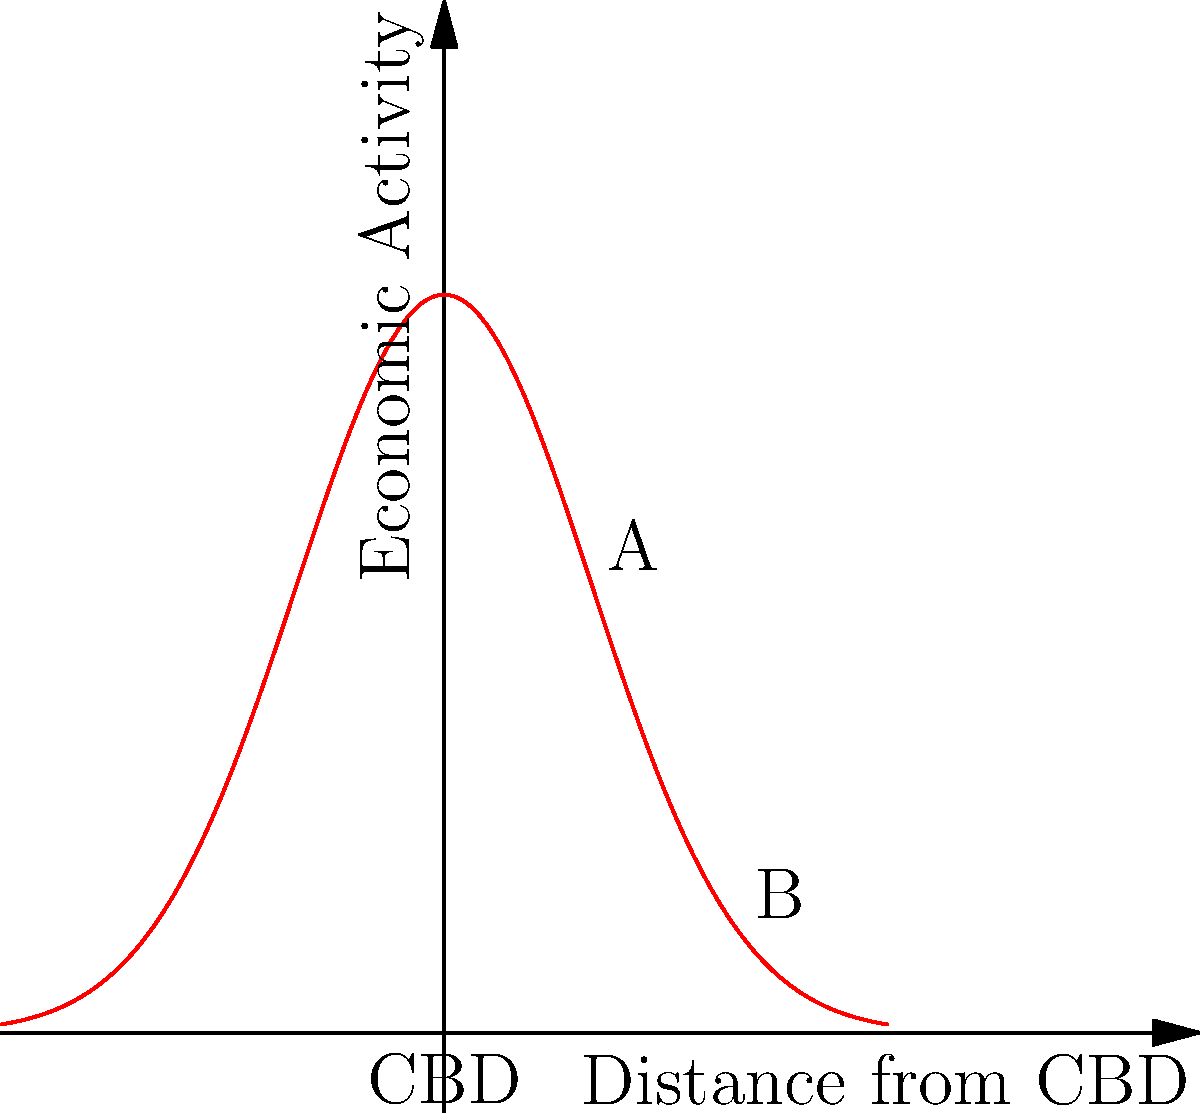The graph represents the distribution of economic activity in an urban area, with the Central Business District (CBD) at the origin. If vector $\vec{v} = \langle 2, f(2) - f(1) \rangle$ represents the change in economic activity from point A to B, what is the magnitude of $\vec{v}$? To find the magnitude of vector $\vec{v}$, we need to follow these steps:

1) First, we need to calculate $f(1)$ and $f(2)$:
   $f(x) = 5e^{-0.5x^2}$
   $f(1) = 5e^{-0.5} \approx 3.03$
   $f(2) = 5e^{-2} \approx 0.68$

2) Now we can define vector $\vec{v}$:
   $\vec{v} = \langle 2, f(2) - f(1) \rangle = \langle 2, 0.68 - 3.03 \rangle = \langle 2, -2.35 \rangle$

3) The magnitude of a vector $\vec{v} = \langle a, b \rangle$ is given by $\|\vec{v}\| = \sqrt{a^2 + b^2}$

4) Substituting our values:
   $\|\vec{v}\| = \sqrt{2^2 + (-2.35)^2}$

5) Calculating:
   $\|\vec{v}\| = \sqrt{4 + 5.5225} = \sqrt{9.5225} \approx 3.09$

Therefore, the magnitude of vector $\vec{v}$ is approximately 3.09 units.
Answer: 3.09 